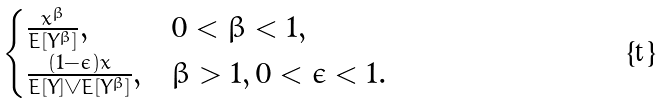Convert formula to latex. <formula><loc_0><loc_0><loc_500><loc_500>\begin{cases} \frac { x ^ { \beta } } { E [ Y ^ { \beta } ] } , & 0 < \beta < 1 , \\ \frac { ( 1 - \epsilon ) x } { E [ Y ] \vee E [ Y ^ { \beta } ] } , & \beta > 1 , 0 < \epsilon < 1 . \end{cases}</formula> 